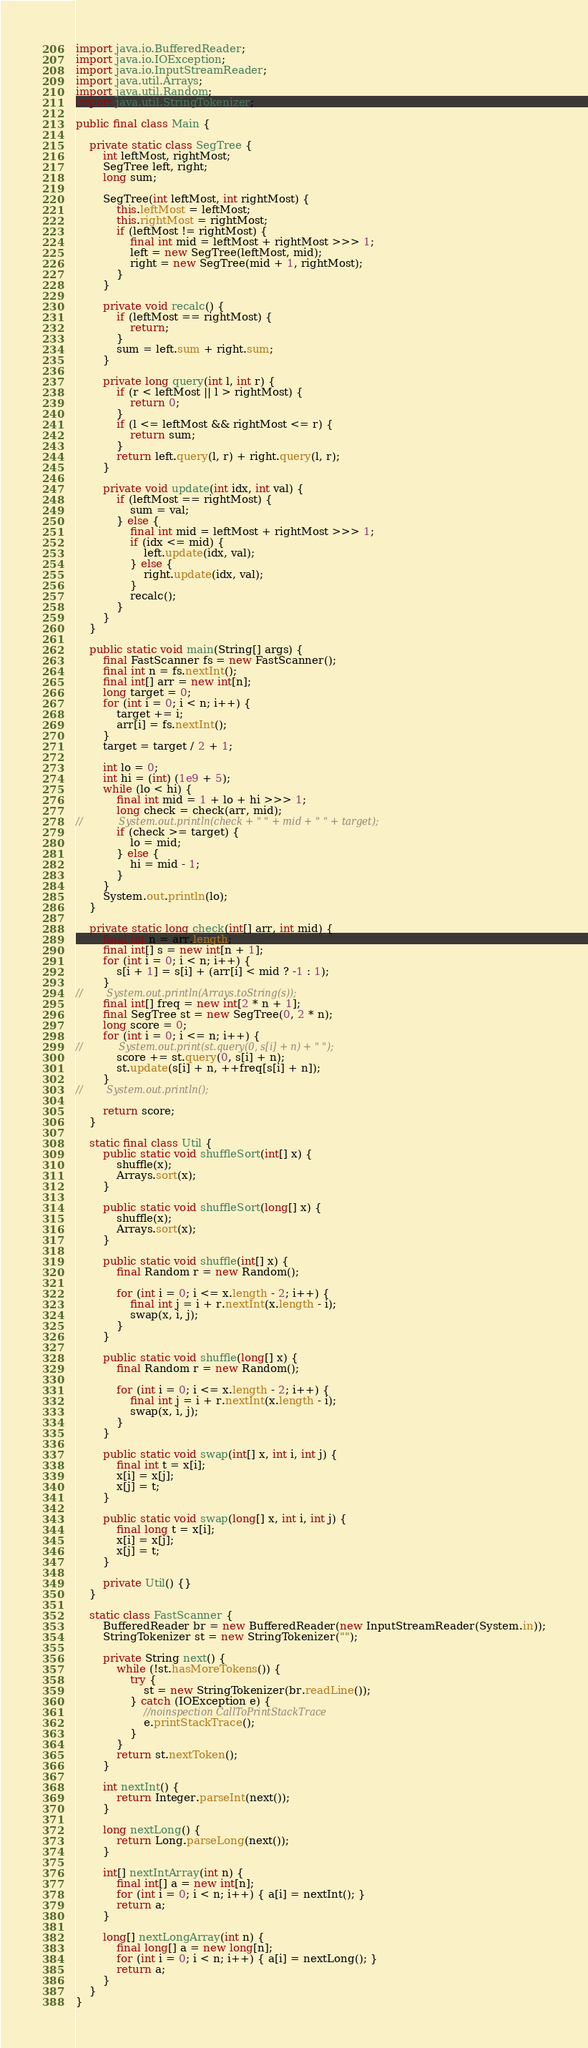<code> <loc_0><loc_0><loc_500><loc_500><_Java_>
import java.io.BufferedReader;
import java.io.IOException;
import java.io.InputStreamReader;
import java.util.Arrays;
import java.util.Random;
import java.util.StringTokenizer;

public final class Main {

    private static class SegTree {
        int leftMost, rightMost;
        SegTree left, right;
        long sum;

        SegTree(int leftMost, int rightMost) {
            this.leftMost = leftMost;
            this.rightMost = rightMost;
            if (leftMost != rightMost) {
                final int mid = leftMost + rightMost >>> 1;
                left = new SegTree(leftMost, mid);
                right = new SegTree(mid + 1, rightMost);
            }
        }

        private void recalc() {
            if (leftMost == rightMost) {
                return;
            }
            sum = left.sum + right.sum;
        }

        private long query(int l, int r) {
            if (r < leftMost || l > rightMost) {
                return 0;
            }
            if (l <= leftMost && rightMost <= r) {
                return sum;
            }
            return left.query(l, r) + right.query(l, r);
        }

        private void update(int idx, int val) {
            if (leftMost == rightMost) {
                sum = val;
            } else {
                final int mid = leftMost + rightMost >>> 1;
                if (idx <= mid) {
                    left.update(idx, val);
                } else {
                    right.update(idx, val);
                }
                recalc();
            }
        }
    }

    public static void main(String[] args) {
        final FastScanner fs = new FastScanner();
        final int n = fs.nextInt();
        final int[] arr = new int[n];
        long target = 0;
        for (int i = 0; i < n; i++) {
            target += i;
            arr[i] = fs.nextInt();
        }
        target = target / 2 + 1;

        int lo = 0;
        int hi = (int) (1e9 + 5);
        while (lo < hi) {
            final int mid = 1 + lo + hi >>> 1;
            long check = check(arr, mid);
//            System.out.println(check + " " + mid + " " + target);
            if (check >= target) {
                lo = mid;
            } else {
                hi = mid - 1;
            }
        }
        System.out.println(lo);
    }

    private static long check(int[] arr, int mid) {
        final int n = arr.length;
        final int[] s = new int[n + 1];
        for (int i = 0; i < n; i++) {
            s[i + 1] = s[i] + (arr[i] < mid ? -1 : 1);
        }
//        System.out.println(Arrays.toString(s));
        final int[] freq = new int[2 * n + 1];
        final SegTree st = new SegTree(0, 2 * n);
        long score = 0;
        for (int i = 0; i <= n; i++) {
//            System.out.print(st.query(0, s[i] + n) + " ");
            score += st.query(0, s[i] + n);
            st.update(s[i] + n, ++freq[s[i] + n]);
        }
//        System.out.println();

        return score;
    }

    static final class Util {
        public static void shuffleSort(int[] x) {
            shuffle(x);
            Arrays.sort(x);
        }

        public static void shuffleSort(long[] x) {
            shuffle(x);
            Arrays.sort(x);
        }

        public static void shuffle(int[] x) {
            final Random r = new Random();

            for (int i = 0; i <= x.length - 2; i++) {
                final int j = i + r.nextInt(x.length - i);
                swap(x, i, j);
            }
        }

        public static void shuffle(long[] x) {
            final Random r = new Random();

            for (int i = 0; i <= x.length - 2; i++) {
                final int j = i + r.nextInt(x.length - i);
                swap(x, i, j);
            }
        }

        public static void swap(int[] x, int i, int j) {
            final int t = x[i];
            x[i] = x[j];
            x[j] = t;
        }

        public static void swap(long[] x, int i, int j) {
            final long t = x[i];
            x[i] = x[j];
            x[j] = t;
        }

        private Util() {}
    }

    static class FastScanner {
        BufferedReader br = new BufferedReader(new InputStreamReader(System.in));
        StringTokenizer st = new StringTokenizer("");

        private String next() {
            while (!st.hasMoreTokens()) {
                try {
                    st = new StringTokenizer(br.readLine());
                } catch (IOException e) {
                    //noinspection CallToPrintStackTrace
                    e.printStackTrace();
                }
            }
            return st.nextToken();
        }

        int nextInt() {
            return Integer.parseInt(next());
        }

        long nextLong() {
            return Long.parseLong(next());
        }

        int[] nextIntArray(int n) {
            final int[] a = new int[n];
            for (int i = 0; i < n; i++) { a[i] = nextInt(); }
            return a;
        }

        long[] nextLongArray(int n) {
            final long[] a = new long[n];
            for (int i = 0; i < n; i++) { a[i] = nextLong(); }
            return a;
        }
    }
}
</code> 